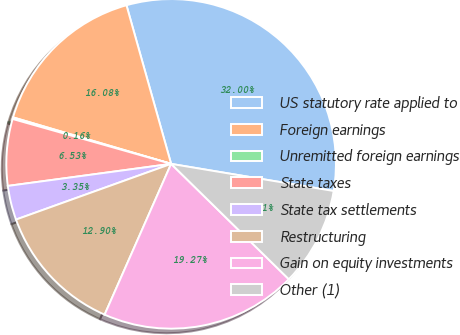<chart> <loc_0><loc_0><loc_500><loc_500><pie_chart><fcel>US statutory rate applied to<fcel>Foreign earnings<fcel>Unremitted foreign earnings<fcel>State taxes<fcel>State tax settlements<fcel>Restructuring<fcel>Gain on equity investments<fcel>Other (1)<nl><fcel>32.0%<fcel>16.08%<fcel>0.16%<fcel>6.53%<fcel>3.35%<fcel>12.9%<fcel>19.27%<fcel>9.71%<nl></chart> 